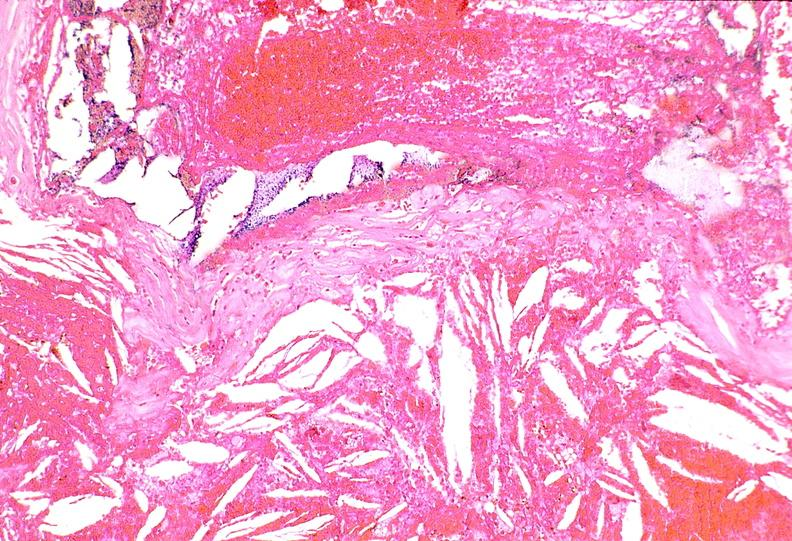what is present?
Answer the question using a single word or phrase. Cardiovascular 